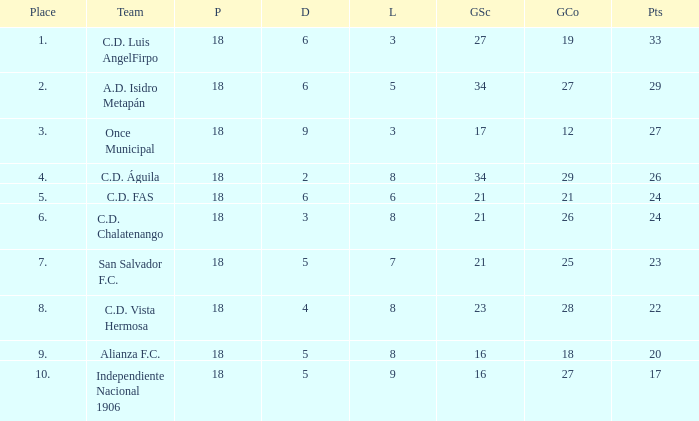What are the number of goals conceded that has a played greater than 18? 0.0. 